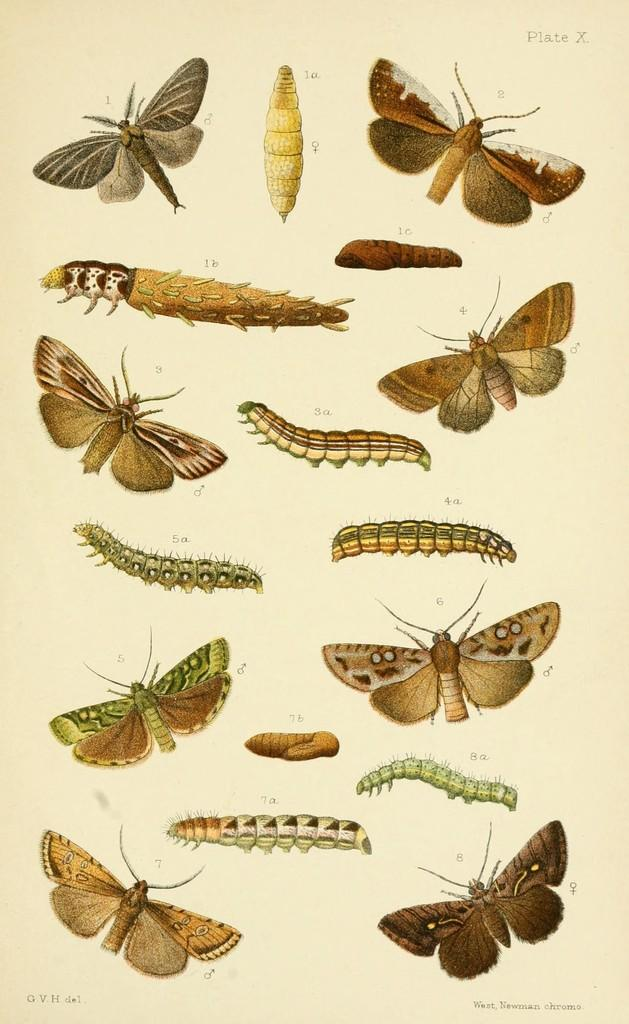What type of animals are present in the image? There are caterpillars and butterflies in the image. What other creatures can be seen in the image? There are also insects in the image. What is the format of the image? The image is a page containing diagrams. What type of pot is visible in the image? There is no pot present in the image. Can you describe the branch that the caterpillars are crawling on in the image? There is no branch visible in the image; the caterpillars are not shown on a branch. 